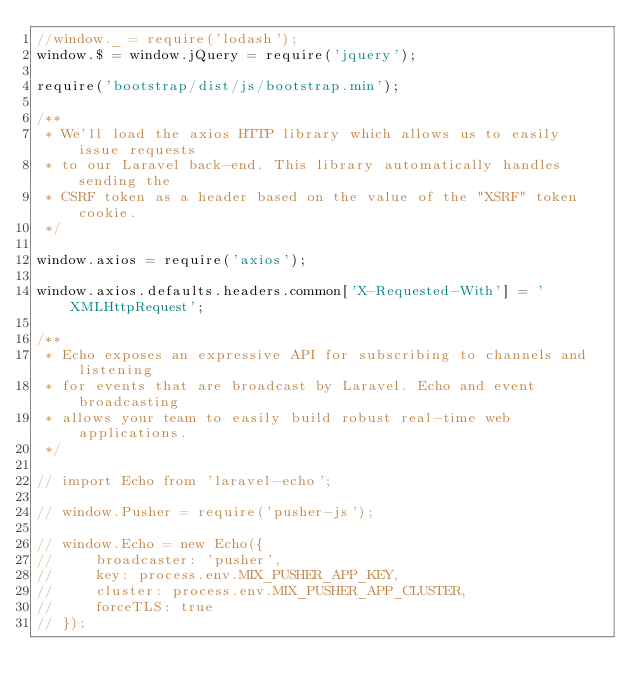Convert code to text. <code><loc_0><loc_0><loc_500><loc_500><_JavaScript_>//window._ = require('lodash');
window.$ = window.jQuery = require('jquery');

require('bootstrap/dist/js/bootstrap.min');

/**
 * We'll load the axios HTTP library which allows us to easily issue requests
 * to our Laravel back-end. This library automatically handles sending the
 * CSRF token as a header based on the value of the "XSRF" token cookie.
 */

window.axios = require('axios');

window.axios.defaults.headers.common['X-Requested-With'] = 'XMLHttpRequest';

/**
 * Echo exposes an expressive API for subscribing to channels and listening
 * for events that are broadcast by Laravel. Echo and event broadcasting
 * allows your team to easily build robust real-time web applications.
 */

// import Echo from 'laravel-echo';

// window.Pusher = require('pusher-js');

// window.Echo = new Echo({
//     broadcaster: 'pusher',
//     key: process.env.MIX_PUSHER_APP_KEY,
//     cluster: process.env.MIX_PUSHER_APP_CLUSTER,
//     forceTLS: true
// });
</code> 